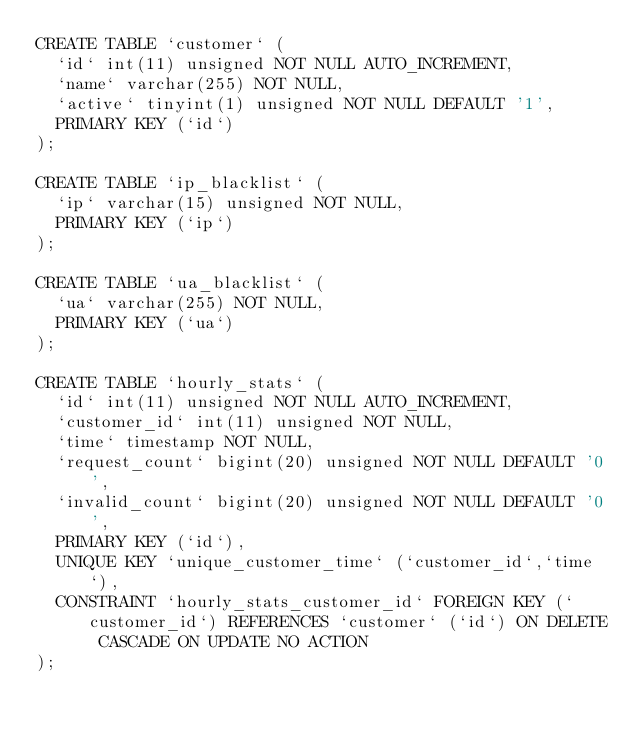<code> <loc_0><loc_0><loc_500><loc_500><_SQL_>CREATE TABLE `customer` (
  `id` int(11) unsigned NOT NULL AUTO_INCREMENT,
  `name` varchar(255) NOT NULL,
  `active` tinyint(1) unsigned NOT NULL DEFAULT '1',
  PRIMARY KEY (`id`)
);

CREATE TABLE `ip_blacklist` (
  `ip` varchar(15) unsigned NOT NULL,
  PRIMARY KEY (`ip`)
);

CREATE TABLE `ua_blacklist` (
  `ua` varchar(255) NOT NULL,
  PRIMARY KEY (`ua`)
);

CREATE TABLE `hourly_stats` (
  `id` int(11) unsigned NOT NULL AUTO_INCREMENT,
  `customer_id` int(11) unsigned NOT NULL,
  `time` timestamp NOT NULL,
  `request_count` bigint(20) unsigned NOT NULL DEFAULT '0',
  `invalid_count` bigint(20) unsigned NOT NULL DEFAULT '0',
  PRIMARY KEY (`id`),
  UNIQUE KEY `unique_customer_time` (`customer_id`,`time`),
  CONSTRAINT `hourly_stats_customer_id` FOREIGN KEY (`customer_id`) REFERENCES `customer` (`id`) ON DELETE CASCADE ON UPDATE NO ACTION
);</code> 